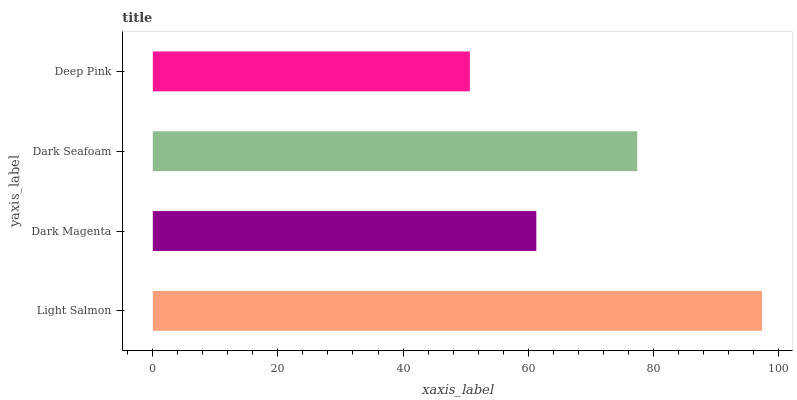Is Deep Pink the minimum?
Answer yes or no. Yes. Is Light Salmon the maximum?
Answer yes or no. Yes. Is Dark Magenta the minimum?
Answer yes or no. No. Is Dark Magenta the maximum?
Answer yes or no. No. Is Light Salmon greater than Dark Magenta?
Answer yes or no. Yes. Is Dark Magenta less than Light Salmon?
Answer yes or no. Yes. Is Dark Magenta greater than Light Salmon?
Answer yes or no. No. Is Light Salmon less than Dark Magenta?
Answer yes or no. No. Is Dark Seafoam the high median?
Answer yes or no. Yes. Is Dark Magenta the low median?
Answer yes or no. Yes. Is Deep Pink the high median?
Answer yes or no. No. Is Dark Seafoam the low median?
Answer yes or no. No. 